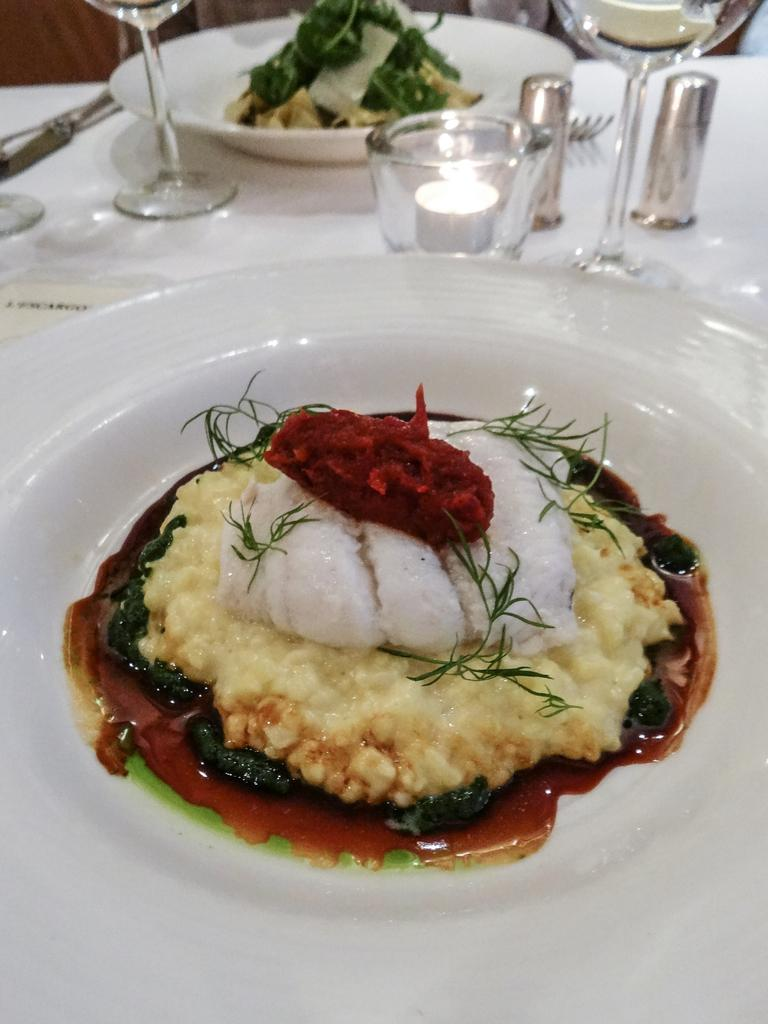What type of dishware can be seen in the image? There are plates in the image. What else is present on the table in the image? There is food and glasses visible in the image. Can you describe the objects on the table in the image? There are objects on the table in the image, but the specific items are not mentioned in the provided facts. What time of day is it in the image, considering the presence of giants? There is no mention of giants in the image, and therefore we cannot determine the time of day based on their presence. 